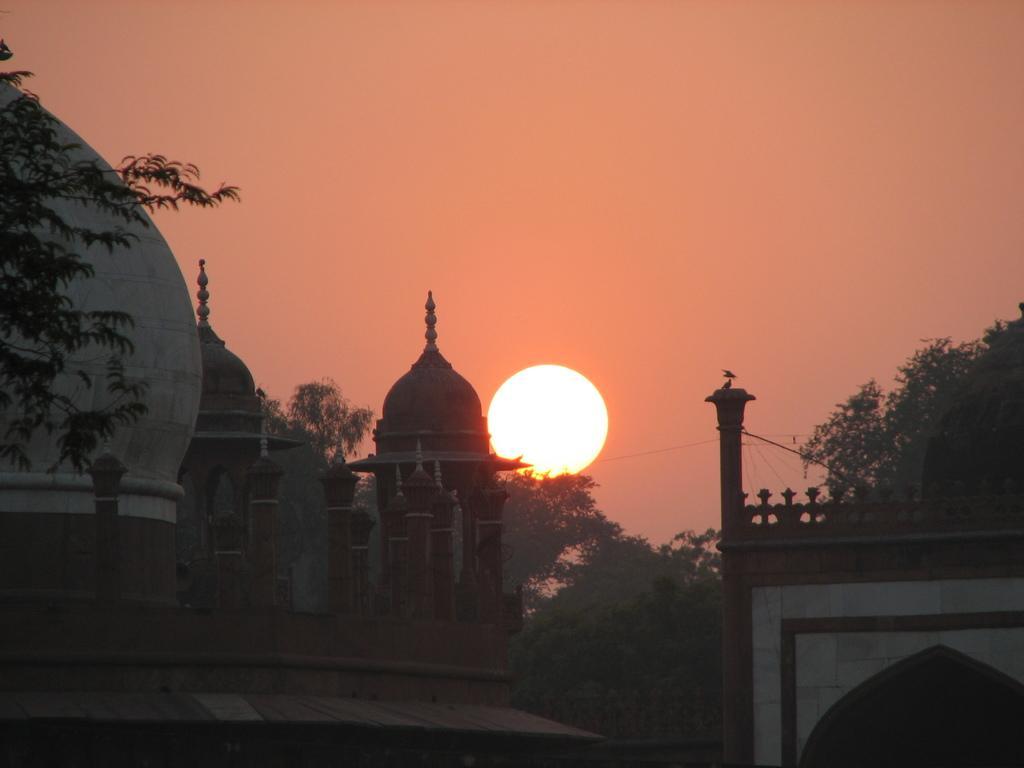Can you describe this image briefly? In this image we can see tomb buildings and trees. We can see sun in the sky. 